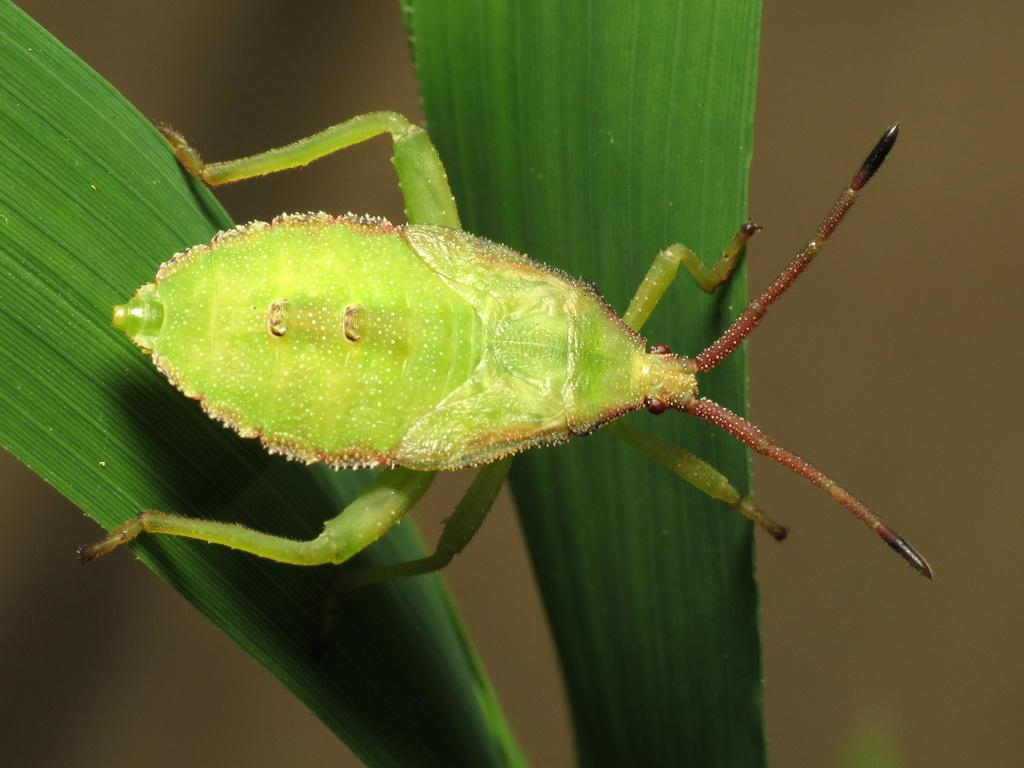What type of creature is visible in the image? There is a green-colored bug in the image. Where is the bug located in the image? The bug is present on a plant. What type of force is being exerted on the bug in the image? There is no indication of any force being exerted on the bug in the image. Can you see a rat in the image? No, there is no rat present in the image. 